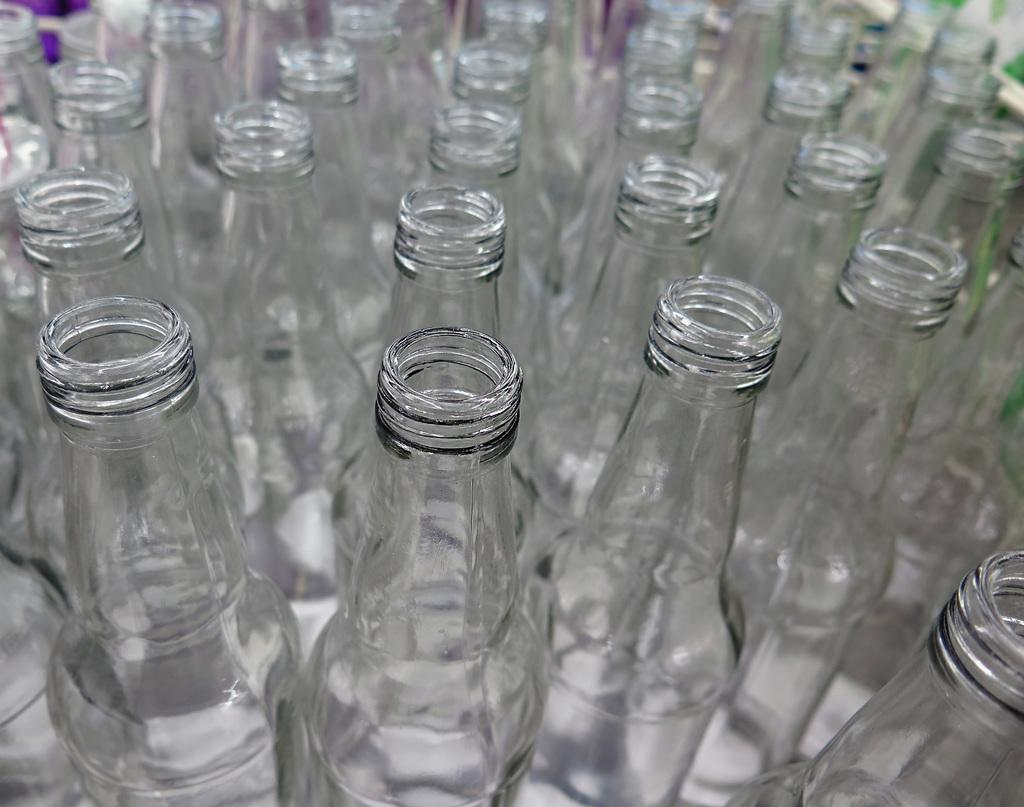What is the main subject of the image? The main subject of the image is a group of bottles. Can you describe the bottles in the image? Unfortunately, the provided facts do not give any details about the bottles, so we cannot describe them further. How does the feeling of winter relate to the group of bottles in the image? The feeling of winter is not present in the image, as it only features a group of bottles. The image does not convey any emotions or seasons. 